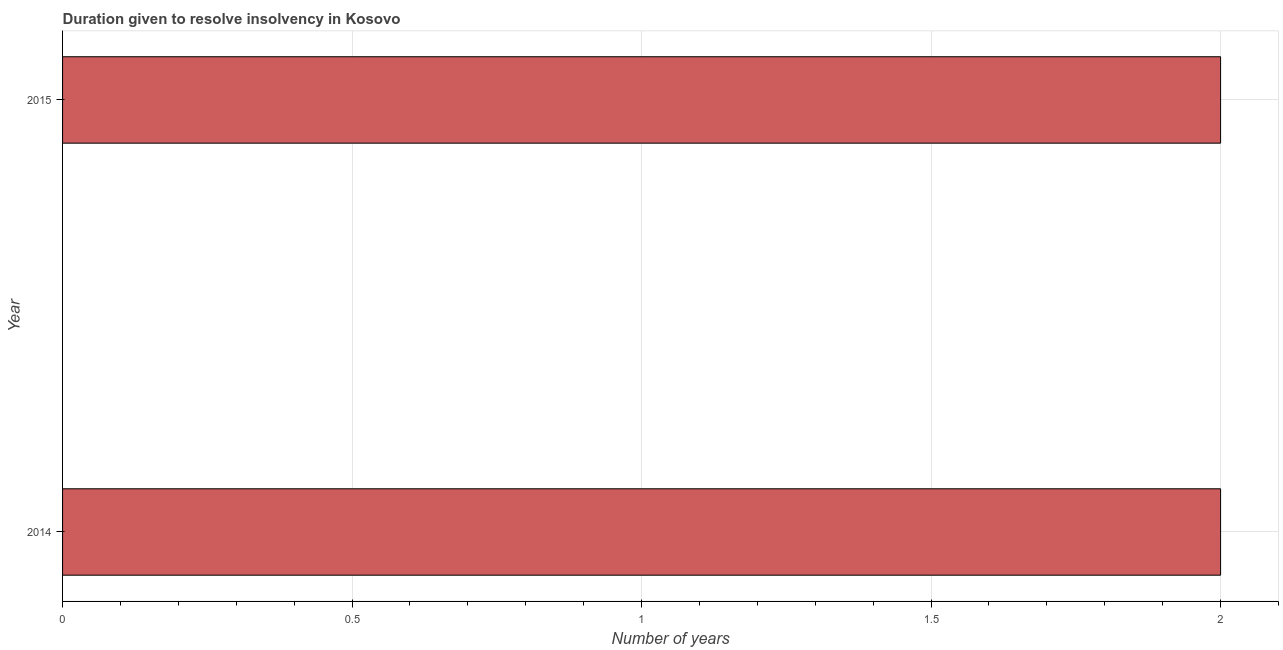Does the graph contain any zero values?
Ensure brevity in your answer.  No. What is the title of the graph?
Provide a succinct answer. Duration given to resolve insolvency in Kosovo. What is the label or title of the X-axis?
Keep it short and to the point. Number of years. What is the label or title of the Y-axis?
Your answer should be very brief. Year. Across all years, what is the maximum number of years to resolve insolvency?
Your response must be concise. 2. Across all years, what is the minimum number of years to resolve insolvency?
Offer a terse response. 2. In which year was the number of years to resolve insolvency maximum?
Provide a succinct answer. 2014. In which year was the number of years to resolve insolvency minimum?
Your response must be concise. 2014. What is the sum of the number of years to resolve insolvency?
Provide a succinct answer. 4. What is the difference between the number of years to resolve insolvency in 2014 and 2015?
Your response must be concise. 0. What is the average number of years to resolve insolvency per year?
Your answer should be very brief. 2. What is the median number of years to resolve insolvency?
Offer a very short reply. 2. In how many years, is the number of years to resolve insolvency greater than 0.7 ?
Ensure brevity in your answer.  2. Do a majority of the years between 2015 and 2014 (inclusive) have number of years to resolve insolvency greater than 1.4 ?
Offer a terse response. No. What is the ratio of the number of years to resolve insolvency in 2014 to that in 2015?
Provide a short and direct response. 1. Is the number of years to resolve insolvency in 2014 less than that in 2015?
Your response must be concise. No. In how many years, is the number of years to resolve insolvency greater than the average number of years to resolve insolvency taken over all years?
Make the answer very short. 0. Are all the bars in the graph horizontal?
Offer a terse response. Yes. Are the values on the major ticks of X-axis written in scientific E-notation?
Make the answer very short. No. What is the Number of years of 2015?
Offer a very short reply. 2. What is the difference between the Number of years in 2014 and 2015?
Your answer should be very brief. 0. 